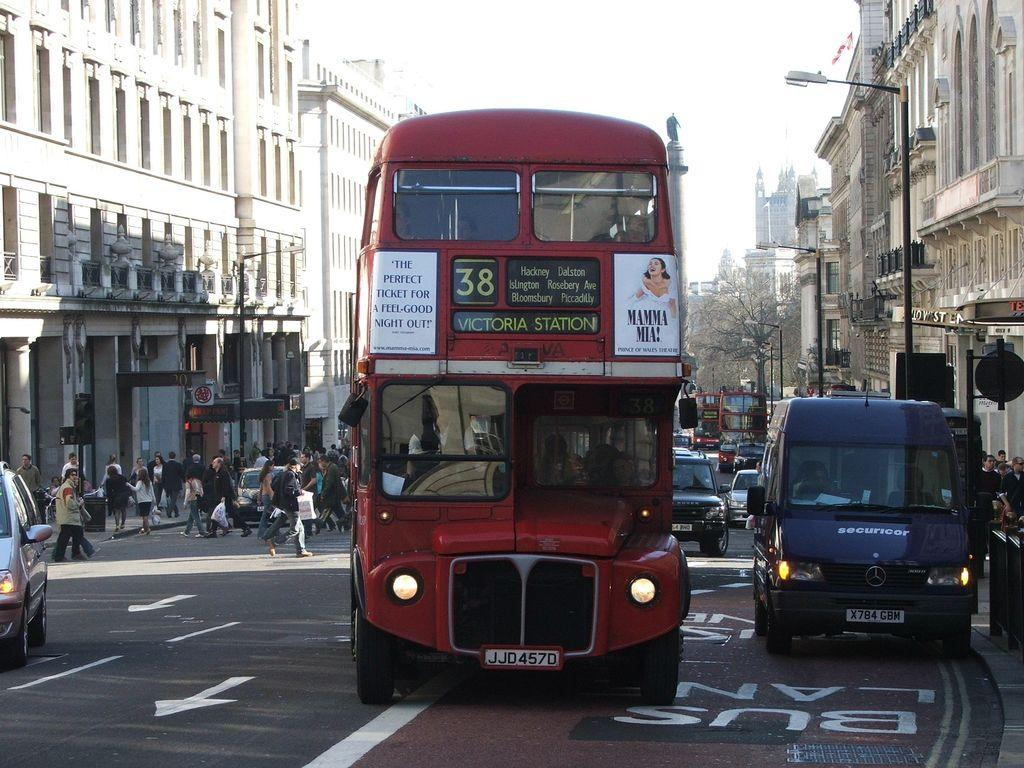What is happening on the road in the image? There are people in vehicles on the road. What else can be seen in the background of the image? There are vehicles, people, buildings, walls, street lights, trees, pillars, and boards in the background. What is visible in the sky in the image? The sky is visible in the background of the image. What type of balls are being used to play in the sand in the image? There is no sand or balls present in the image. 